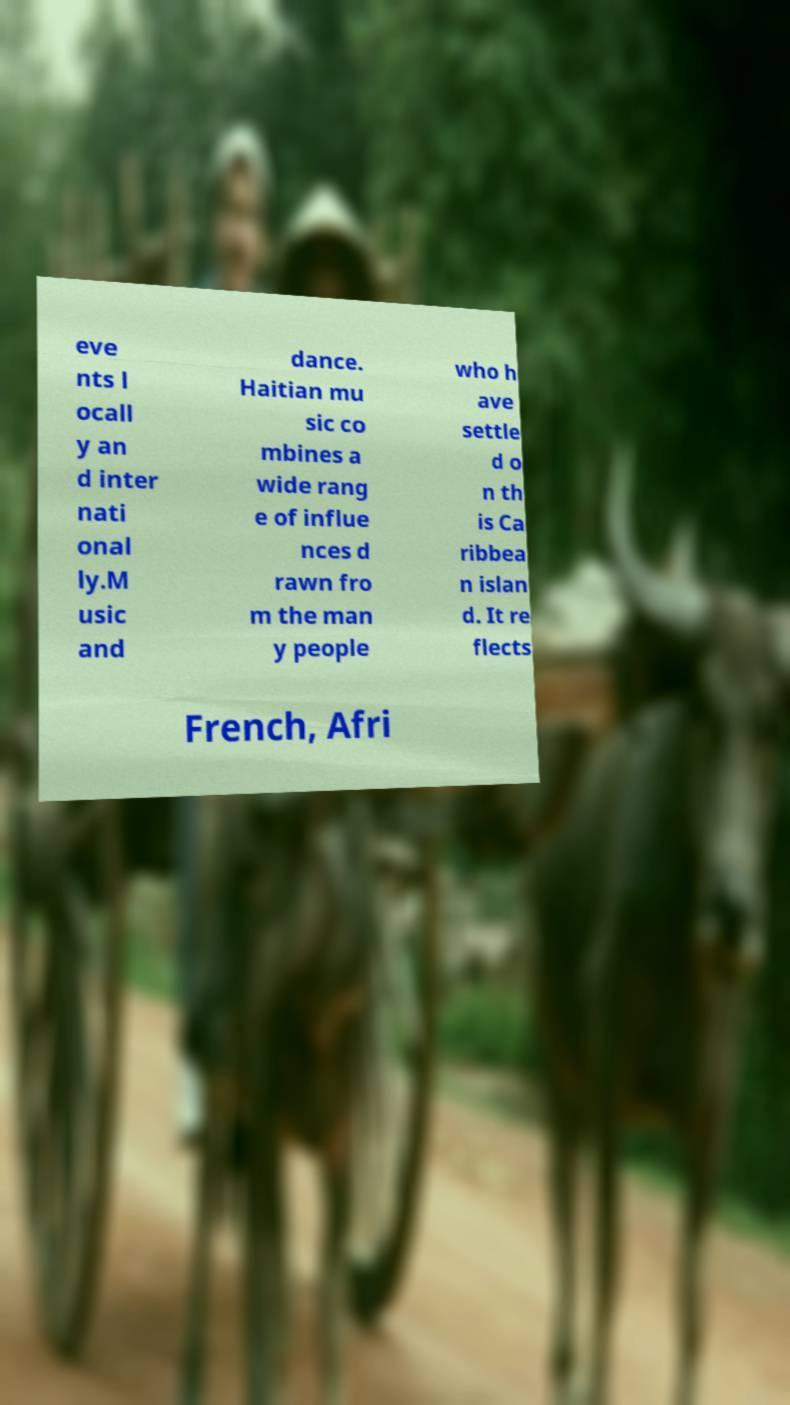For documentation purposes, I need the text within this image transcribed. Could you provide that? eve nts l ocall y an d inter nati onal ly.M usic and dance. Haitian mu sic co mbines a wide rang e of influe nces d rawn fro m the man y people who h ave settle d o n th is Ca ribbea n islan d. It re flects French, Afri 